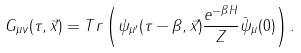<formula> <loc_0><loc_0><loc_500><loc_500>G _ { \mu \nu } ( \tau , \vec { x } ) = T r \left ( \psi _ { \mu ^ { \prime } } ( \tau - \beta , \vec { x } ) \frac { e ^ { - \beta H } } { Z } \bar { \psi } _ { \mu } ( 0 ) \right ) .</formula> 